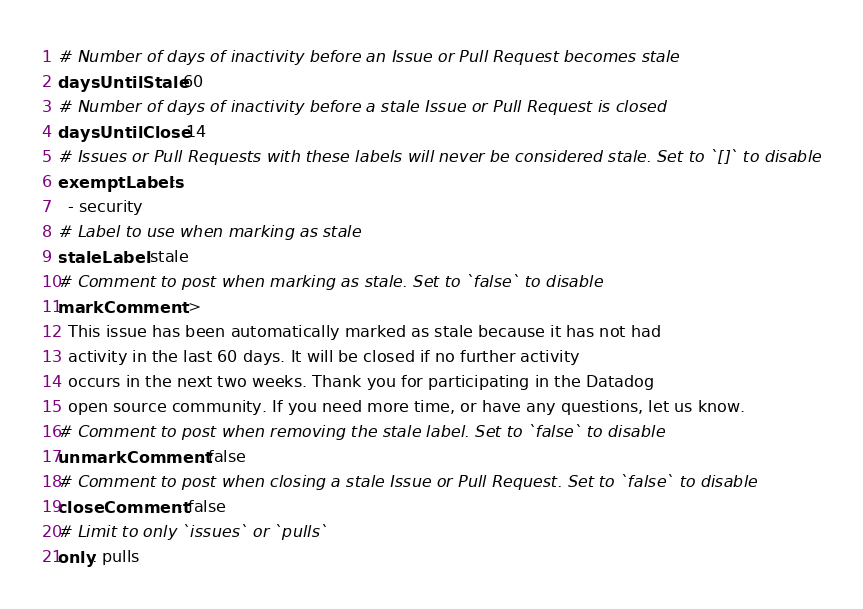Convert code to text. <code><loc_0><loc_0><loc_500><loc_500><_YAML_># Number of days of inactivity before an Issue or Pull Request becomes stale
daysUntilStale: 60
# Number of days of inactivity before a stale Issue or Pull Request is closed
daysUntilClose: 14
# Issues or Pull Requests with these labels will never be considered stale. Set to `[]` to disable
exemptLabels:
  - security
# Label to use when marking as stale
staleLabel: stale
# Comment to post when marking as stale. Set to `false` to disable
markComment: >
  This issue has been automatically marked as stale because it has not had
  activity in the last 60 days. It will be closed if no further activity
  occurs in the next two weeks. Thank you for participating in the Datadog
  open source community. If you need more time, or have any questions, let us know.
# Comment to post when removing the stale label. Set to `false` to disable
unmarkComment: false
# Comment to post when closing a stale Issue or Pull Request. Set to `false` to disable
closeComment: false
# Limit to only `issues` or `pulls`
only: pulls
</code> 